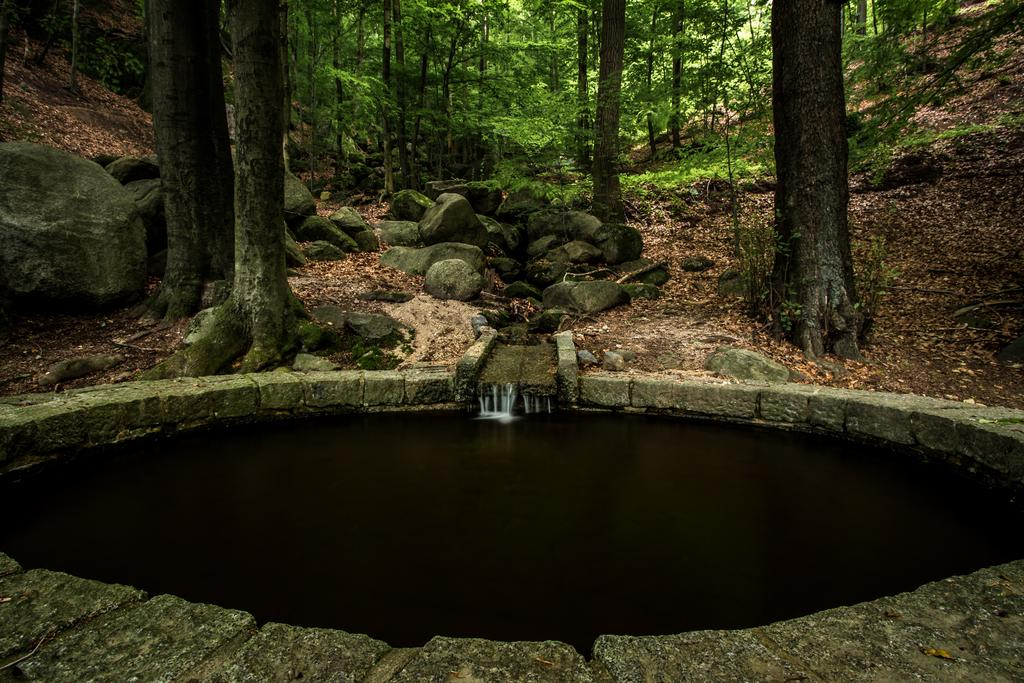What is visible in the image? Water is visible in the image. What can be seen in the background of the image? There are trees and stones in the background of the image. How many ants are crawling on the baseball in the image? There is no baseball present in the image, so it is not possible to determine how many ants might be crawling on it. 